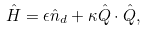Convert formula to latex. <formula><loc_0><loc_0><loc_500><loc_500>\hat { H } = \epsilon \hat { n } _ { d } + \kappa \hat { Q } \cdot \hat { Q } ,</formula> 